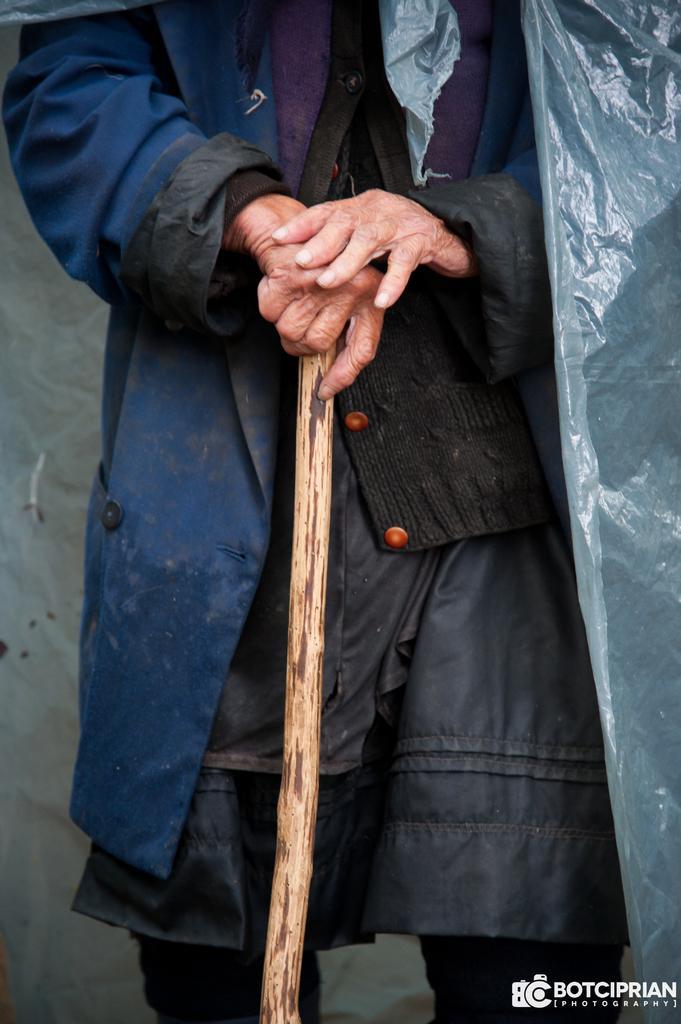Could you give a brief overview of what you see in this image? In this picture I can see a human standing holding a stick and human wore a coat and a polythene cover and I can see text at the bottom right corner of the picture. 